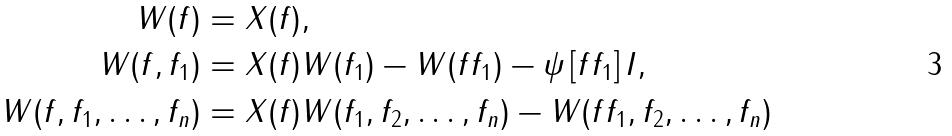Convert formula to latex. <formula><loc_0><loc_0><loc_500><loc_500>W ( f ) & = X ( f ) , \\ W ( f , f _ { 1 } ) & = X ( f ) W ( f _ { 1 } ) - W ( f f _ { 1 } ) - \psi \left [ f f _ { 1 } \right ] I , \\ W ( f , f _ { 1 } , \dots , f _ { n } ) & = X ( f ) W ( f _ { 1 } , f _ { 2 } , \dots , f _ { n } ) - W ( f f _ { 1 } , f _ { 2 } , \dots , f _ { n } )</formula> 